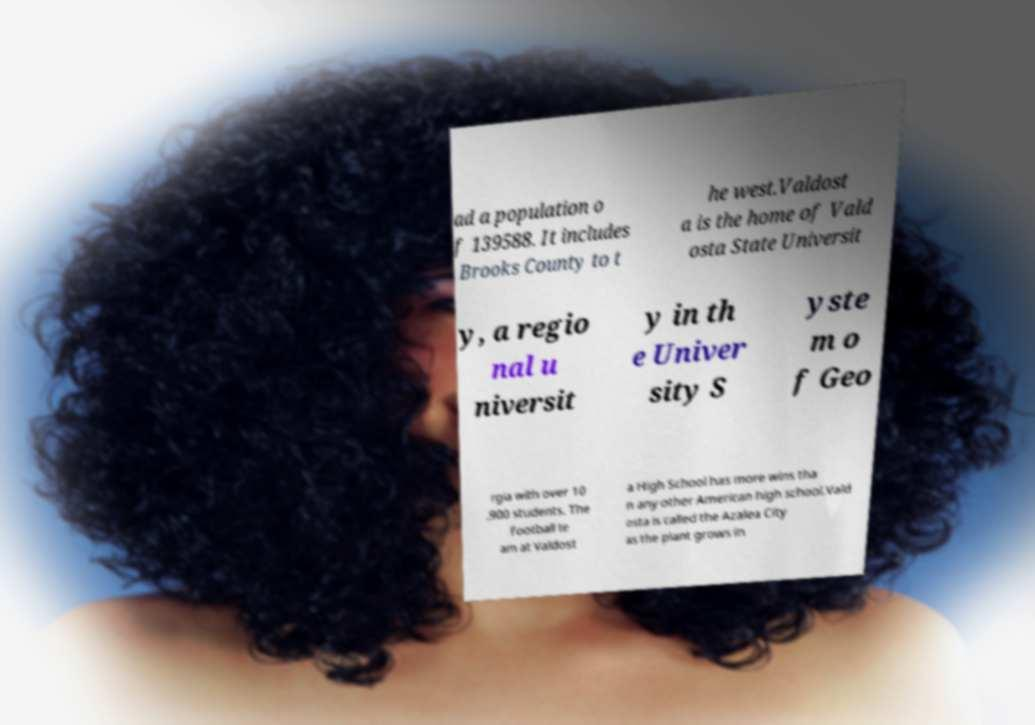What messages or text are displayed in this image? I need them in a readable, typed format. ad a population o f 139588. It includes Brooks County to t he west.Valdost a is the home of Vald osta State Universit y, a regio nal u niversit y in th e Univer sity S yste m o f Geo rgia with over 10 ,900 students. The football te am at Valdost a High School has more wins tha n any other American high school.Vald osta is called the Azalea City as the plant grows in 